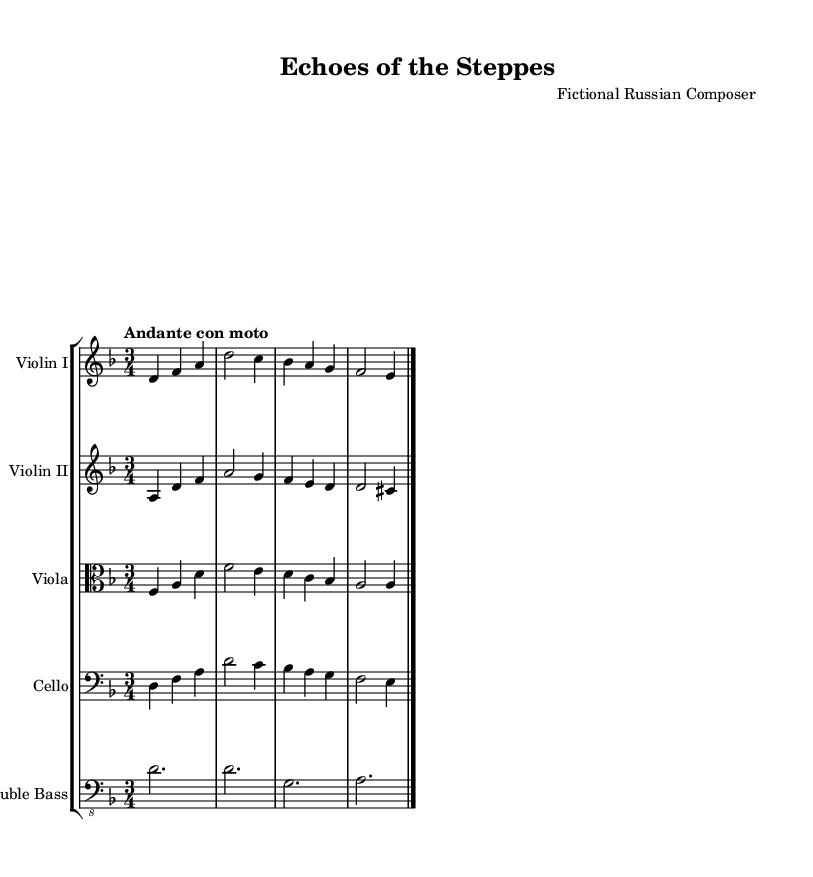What is the key signature of this music? The key signature is D minor, which has one flat (B flat) indicated at the beginning of the staff.
Answer: D minor What is the time signature of the piece? The time signature is 3/4, shown by the numbers at the beginning of the staff, which means there are three beats per measure and the quarter note gets one beat.
Answer: 3/4 What is the tempo marking of this piece? The tempo marking is "Andante con moto," which is indicated above the staff and suggests a moderate and flowing speed.
Answer: Andante con moto How many measures are in the first violin part? There are four measures in the first violin part, as indicated by the grouping of the notes and the barlines seen at the end of each segment.
Answer: Four Which instruments are included in this score? The instruments included in this score are Violin I, Violin II, Viola, Cello, and Double Bass, as labeled at the start of each staff section.
Answer: Violin I, Violin II, Viola, Cello, Double Bass What is the last note in the viola part? The last note in the viola part is A, which is indicated by the final note of the last measure before the barline.
Answer: A How many staves are there in total? There are five staves in total, corresponding to the five different instruments indicated, each having its own staff for music notation.
Answer: Five 